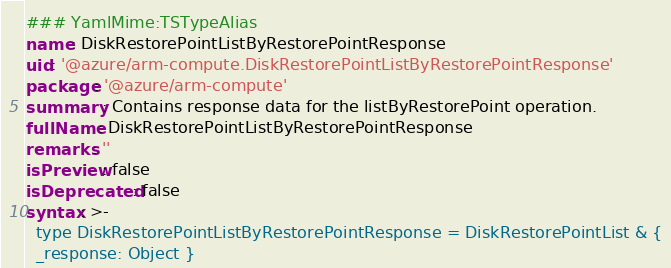<code> <loc_0><loc_0><loc_500><loc_500><_YAML_>### YamlMime:TSTypeAlias
name: DiskRestorePointListByRestorePointResponse
uid: '@azure/arm-compute.DiskRestorePointListByRestorePointResponse'
package: '@azure/arm-compute'
summary: Contains response data for the listByRestorePoint operation.
fullName: DiskRestorePointListByRestorePointResponse
remarks: ''
isPreview: false
isDeprecated: false
syntax: >-
  type DiskRestorePointListByRestorePointResponse = DiskRestorePointList & {
  _response: Object }
</code> 